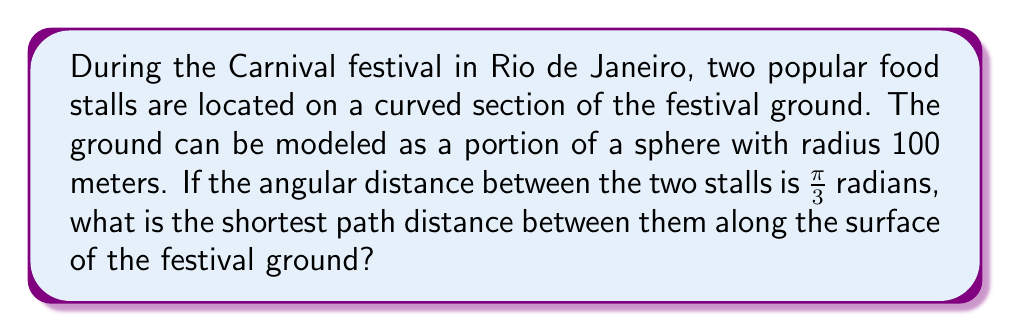Can you answer this question? To solve this problem, we need to use the concept of geodesics on a sphere. The shortest path between two points on a sphere is along a great circle, which is the intersection of the sphere with a plane passing through its center and the two points.

Let's approach this step-by-step:

1) The formula for the arc length $s$ along a great circle on a sphere is:

   $$s = r\theta$$

   where $r$ is the radius of the sphere and $\theta$ is the central angle in radians.

2) We are given:
   - Radius of the sphere (festival ground): $r = 100$ meters
   - Angular distance between the stalls: $\theta = \frac{\pi}{3}$ radians

3) Substituting these values into the formula:

   $$s = 100 \cdot \frac{\pi}{3}$$

4) Simplifying:

   $$s = \frac{100\pi}{3} \approx 104.72$$

Therefore, the shortest path distance between the two food stalls along the curved festival ground is approximately 104.72 meters.

[asy]
import geometry;

size(200);
pair O = (0,0);
real r = 5;
draw(Circle(O,r));
pair A = (r,0);
pair B = r*dir(60);
draw(A--O--B);
draw(Arc(O,A,B),linewidth(1.5));
label("O",O,SW);
label("A",A,E);
label("B",B,NE);
label("$\frac{\pi}{3}$",O,NE);
label("100m",O--A,SE);
label("Shortest path",Arc(O,A,B),N);
[/asy]
Answer: $\frac{100\pi}{3}$ meters or approximately 104.72 meters 